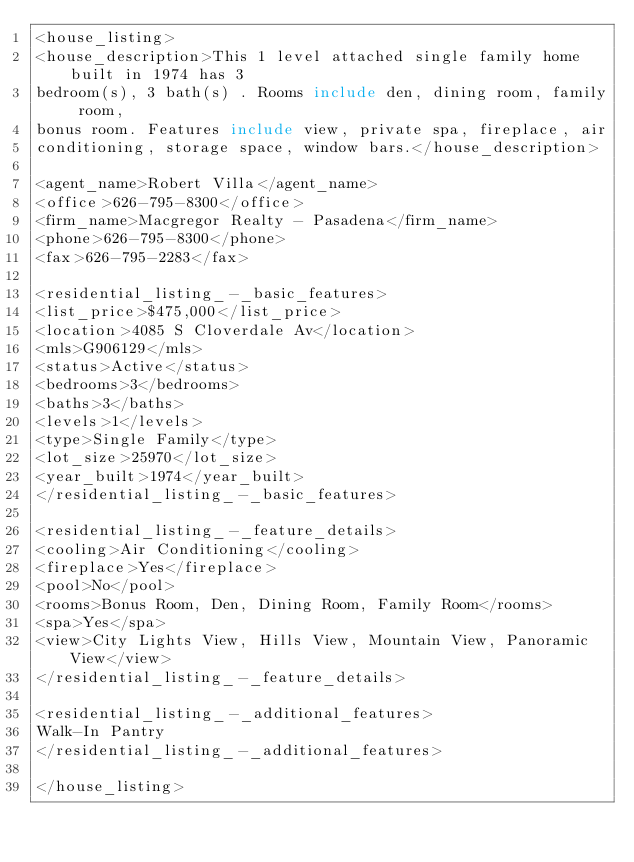Convert code to text. <code><loc_0><loc_0><loc_500><loc_500><_XML_><house_listing>
<house_description>This 1 level attached single family home built in 1974 has 3
bedroom(s), 3 bath(s) . Rooms include den, dining room, family room,
bonus room. Features include view, private spa, fireplace, air
conditioning, storage space, window bars.</house_description>

<agent_name>Robert Villa</agent_name>
<office>626-795-8300</office>
<firm_name>Macgregor Realty - Pasadena</firm_name>
<phone>626-795-8300</phone>
<fax>626-795-2283</fax>

<residential_listing_-_basic_features>
<list_price>$475,000</list_price>
<location>4085 S Cloverdale Av</location>
<mls>G906129</mls>
<status>Active</status>
<bedrooms>3</bedrooms>
<baths>3</baths>
<levels>1</levels>
<type>Single Family</type>
<lot_size>25970</lot_size>
<year_built>1974</year_built>
</residential_listing_-_basic_features>

<residential_listing_-_feature_details>
<cooling>Air Conditioning</cooling>
<fireplace>Yes</fireplace>
<pool>No</pool>
<rooms>Bonus Room, Den, Dining Room, Family Room</rooms>
<spa>Yes</spa>
<view>City Lights View, Hills View, Mountain View, Panoramic View</view>
</residential_listing_-_feature_details>

<residential_listing_-_additional_features>
Walk-In Pantry
</residential_listing_-_additional_features>

</house_listing>



</code> 